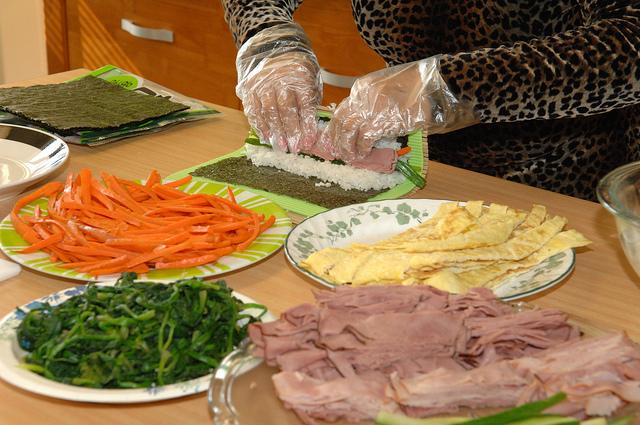What dish is the person assembling these food items to mimic?

Choices:
A) sushi
B) burritos
C) tacos
D) pizza sushi 